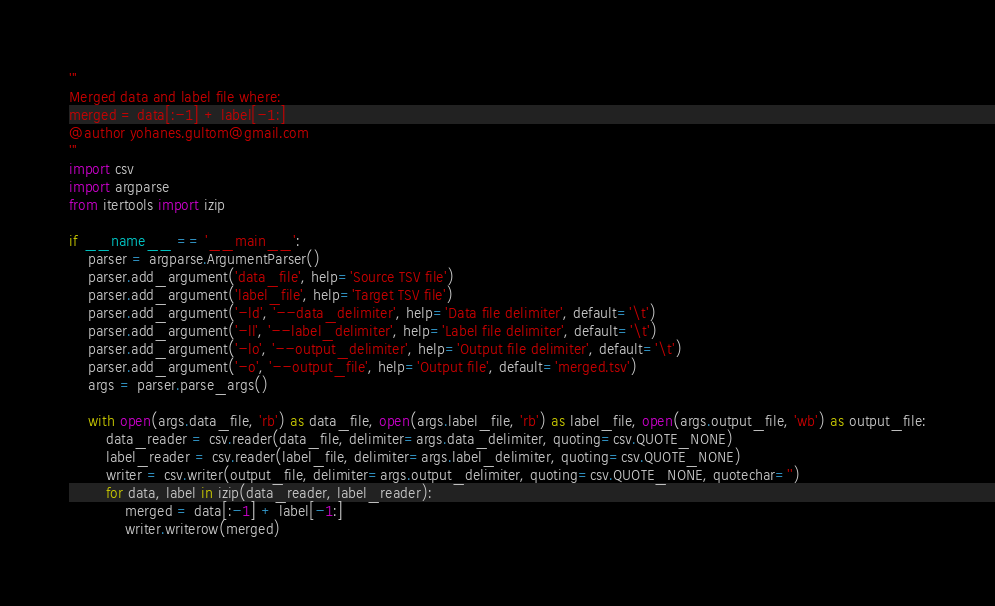<code> <loc_0><loc_0><loc_500><loc_500><_Python_>'''
Merged data and label file where:
merged = data[:-1] + label[-1:]
@author yohanes.gultom@gmail.com
'''
import csv
import argparse
from itertools import izip

if __name__ == '__main__':
    parser = argparse.ArgumentParser()
    parser.add_argument('data_file', help='Source TSV file')
    parser.add_argument('label_file', help='Target TSV file')
    parser.add_argument('-ld', '--data_delimiter', help='Data file delimiter', default='\t')
    parser.add_argument('-ll', '--label_delimiter', help='Label file delimiter', default='\t')
    parser.add_argument('-lo', '--output_delimiter', help='Output file delimiter', default='\t')
    parser.add_argument('-o', '--output_file', help='Output file', default='merged.tsv')
    args = parser.parse_args()

    with open(args.data_file, 'rb') as data_file, open(args.label_file, 'rb') as label_file, open(args.output_file, 'wb') as output_file:
        data_reader = csv.reader(data_file, delimiter=args.data_delimiter, quoting=csv.QUOTE_NONE)
        label_reader = csv.reader(label_file, delimiter=args.label_delimiter, quoting=csv.QUOTE_NONE)
        writer = csv.writer(output_file, delimiter=args.output_delimiter, quoting=csv.QUOTE_NONE, quotechar='')
        for data, label in izip(data_reader, label_reader):
            merged = data[:-1] + label[-1:]
            writer.writerow(merged)
</code> 